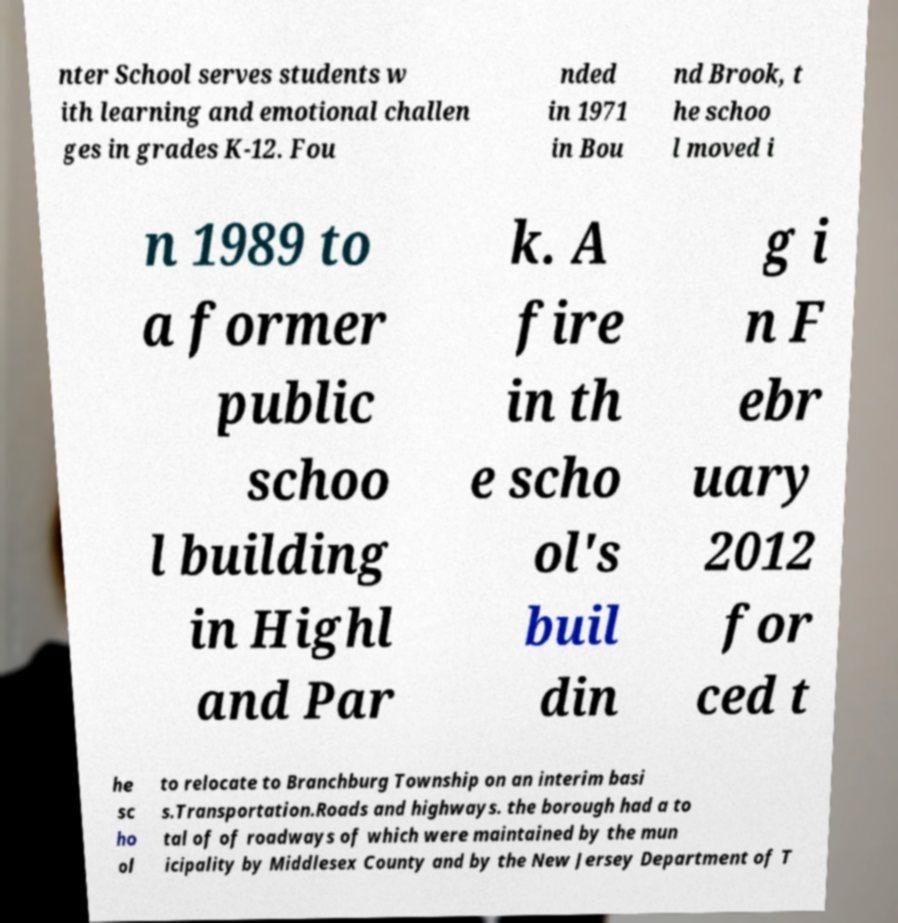I need the written content from this picture converted into text. Can you do that? nter School serves students w ith learning and emotional challen ges in grades K-12. Fou nded in 1971 in Bou nd Brook, t he schoo l moved i n 1989 to a former public schoo l building in Highl and Par k. A fire in th e scho ol's buil din g i n F ebr uary 2012 for ced t he sc ho ol to relocate to Branchburg Township on an interim basi s.Transportation.Roads and highways. the borough had a to tal of of roadways of which were maintained by the mun icipality by Middlesex County and by the New Jersey Department of T 